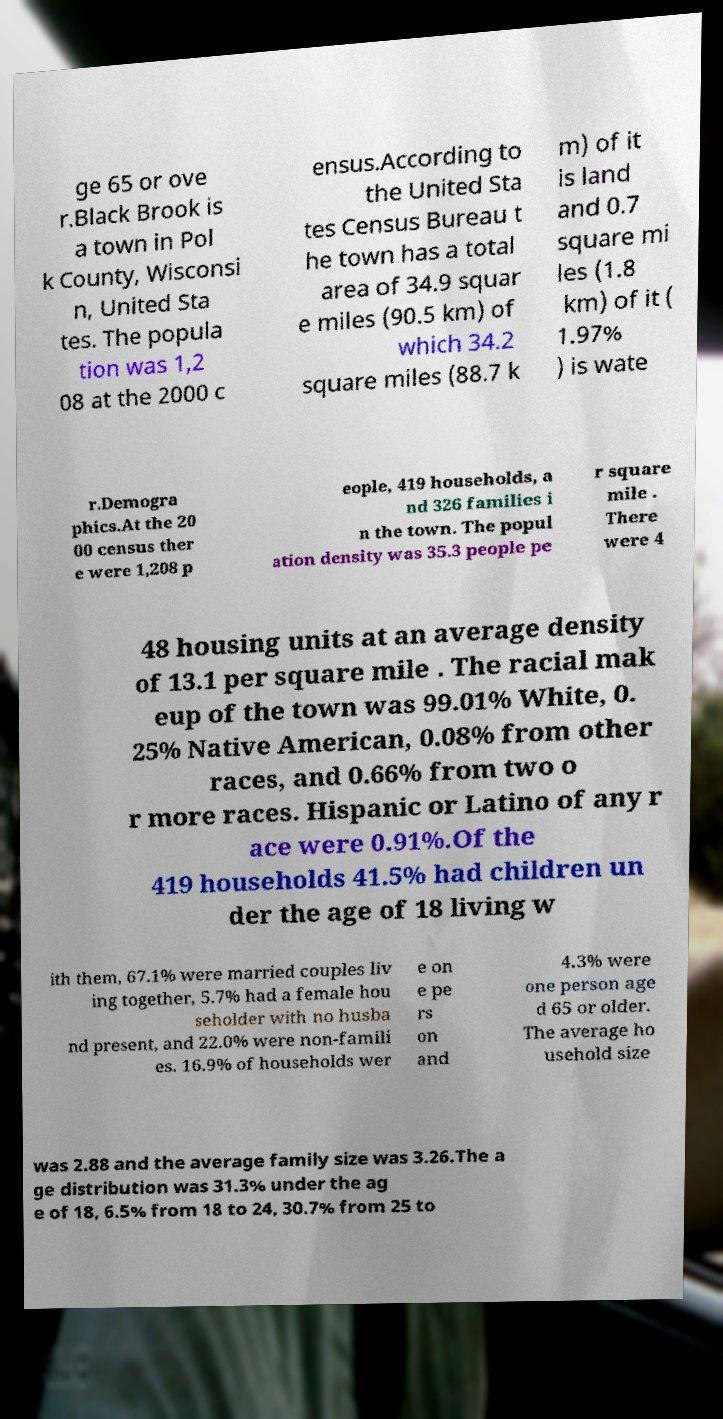Could you extract and type out the text from this image? ge 65 or ove r.Black Brook is a town in Pol k County, Wisconsi n, United Sta tes. The popula tion was 1,2 08 at the 2000 c ensus.According to the United Sta tes Census Bureau t he town has a total area of 34.9 squar e miles (90.5 km) of which 34.2 square miles (88.7 k m) of it is land and 0.7 square mi les (1.8 km) of it ( 1.97% ) is wate r.Demogra phics.At the 20 00 census ther e were 1,208 p eople, 419 households, a nd 326 families i n the town. The popul ation density was 35.3 people pe r square mile . There were 4 48 housing units at an average density of 13.1 per square mile . The racial mak eup of the town was 99.01% White, 0. 25% Native American, 0.08% from other races, and 0.66% from two o r more races. Hispanic or Latino of any r ace were 0.91%.Of the 419 households 41.5% had children un der the age of 18 living w ith them, 67.1% were married couples liv ing together, 5.7% had a female hou seholder with no husba nd present, and 22.0% were non-famili es. 16.9% of households wer e on e pe rs on and 4.3% were one person age d 65 or older. The average ho usehold size was 2.88 and the average family size was 3.26.The a ge distribution was 31.3% under the ag e of 18, 6.5% from 18 to 24, 30.7% from 25 to 